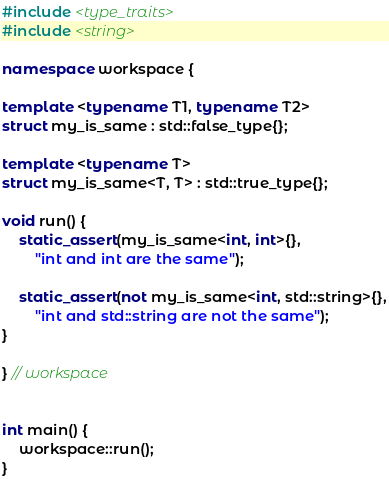Convert code to text. <code><loc_0><loc_0><loc_500><loc_500><_C++_>#include <type_traits>
#include <string>

namespace workspace {

template <typename T1, typename T2>
struct my_is_same : std::false_type{};
    
template <typename T>
struct my_is_same<T, T> : std::true_type{};
    
void run() {
    static_assert(my_is_same<int, int>{},
        "int and int are the same");
    
    static_assert(not my_is_same<int, std::string>{},
        "int and std::string are not the same");
}

} // workspace 


int main() {
    workspace::run();
}
</code> 